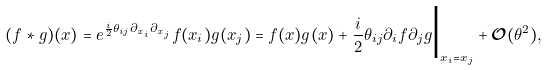Convert formula to latex. <formula><loc_0><loc_0><loc_500><loc_500>( f \ast g ) ( x ) = e ^ { \frac { i } { 2 } \theta _ { i j } \partial _ { x _ { i } } \partial _ { x _ { j } } } f ( x _ { i } ) g ( x _ { j } ) = f ( x ) g ( x ) + \frac { i } { 2 } \theta _ { i j } \partial _ { i } f \partial _ { j } g \Big | _ { x _ { i } = x _ { j } } + { \mathcal { O } } ( \theta ^ { 2 } ) ,</formula> 